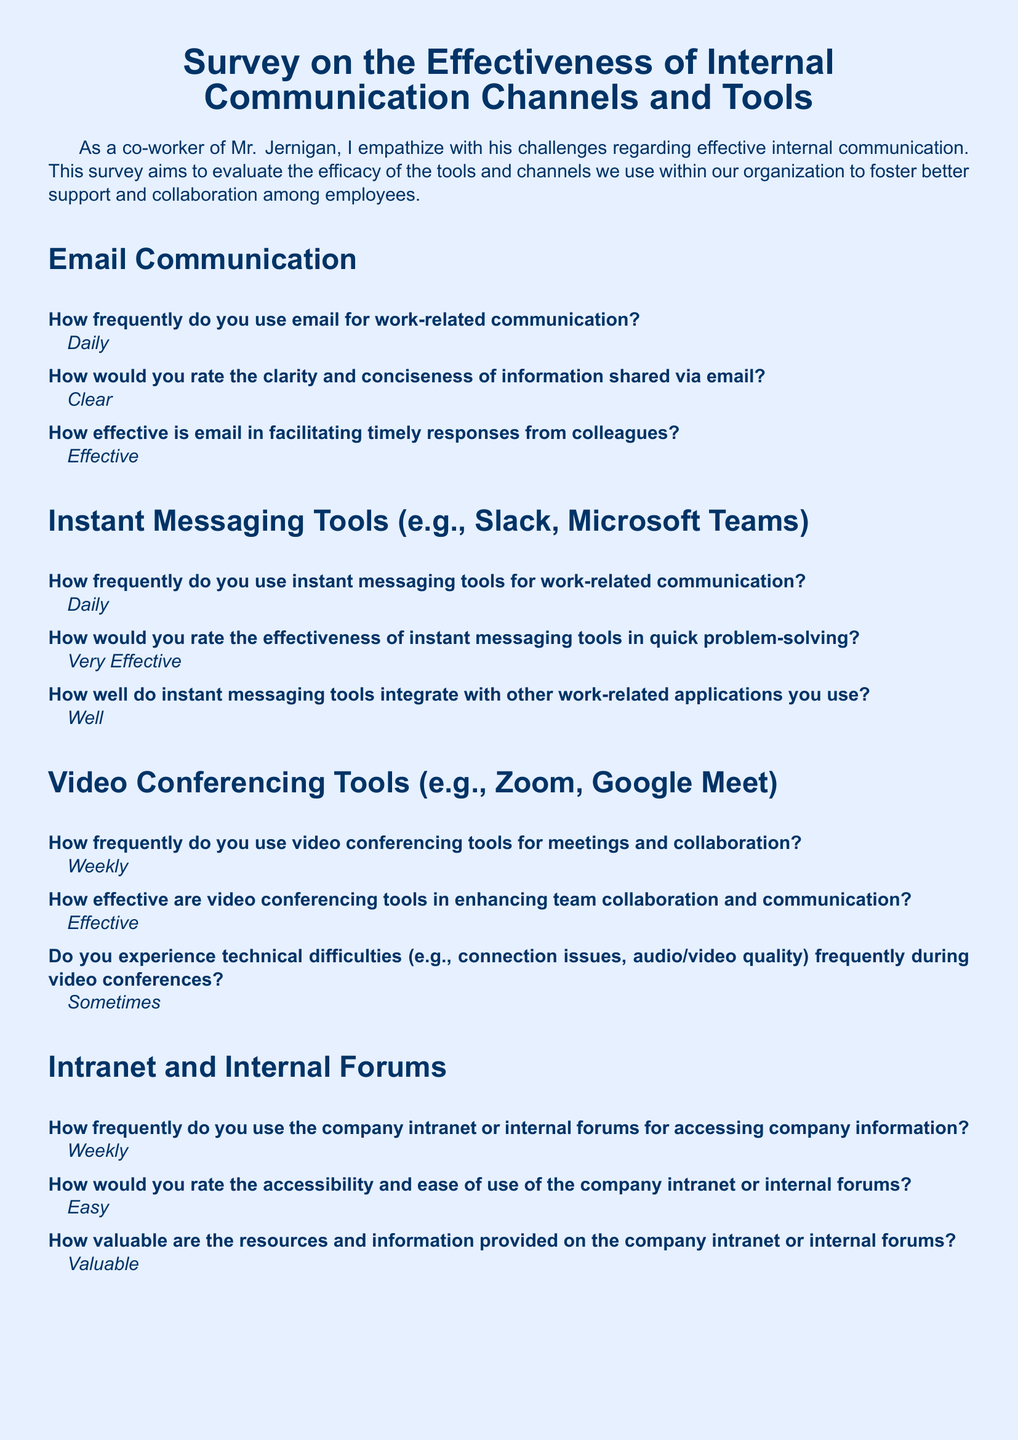What is the frequency of email usage for work-related communication? The survey response indicates how often employees use email for communication, which is stated as "Daily."
Answer: Daily How effective are instant messaging tools in quick problem-solving? This question extracts the effectiveness rating of instant messaging tools as per the survey, which is "Very Effective."
Answer: Very Effective How often do employees use video conferencing tools for meetings? The response specifies how frequently video conferencing tools are used, which is noted as "Weekly."
Answer: Weekly What rating is given for the accessibility of the company intranet? This question refers to the rating of accessibility and ease of use provided in the survey, which is "Easy."
Answer: Easy What is the biggest challenge faced with current internal communication tools? This explores the main issue highlighted in the responses, which is information overload and difficulty in prioritizing messages.
Answer: Information overload and difficulty in prioritizing messages across multiple platforms How often do employees experience technical difficulties during video conferences? The question seeks the frequency at which technical issues occur, which is mentioned as "Sometimes."
Answer: Sometimes What is one suggestion made for improving internal communication? This question aims to summarize the suggestions provided for better internal communication, specifically referring to creating a unified platform.
Answer: Implement a unified communication platform that integrates all tools and provides better message filtering and prioritization features How effective are video conferencing tools in enhancing team collaboration? This question looks for the effectiveness rating given for video conferencing, which is stated as "Effective."
Answer: Effective What is the frequency of using internal forums for accessing company information? Here, the answer extracts how often employees use the internal forums, indicated as "Weekly."
Answer: Weekly 